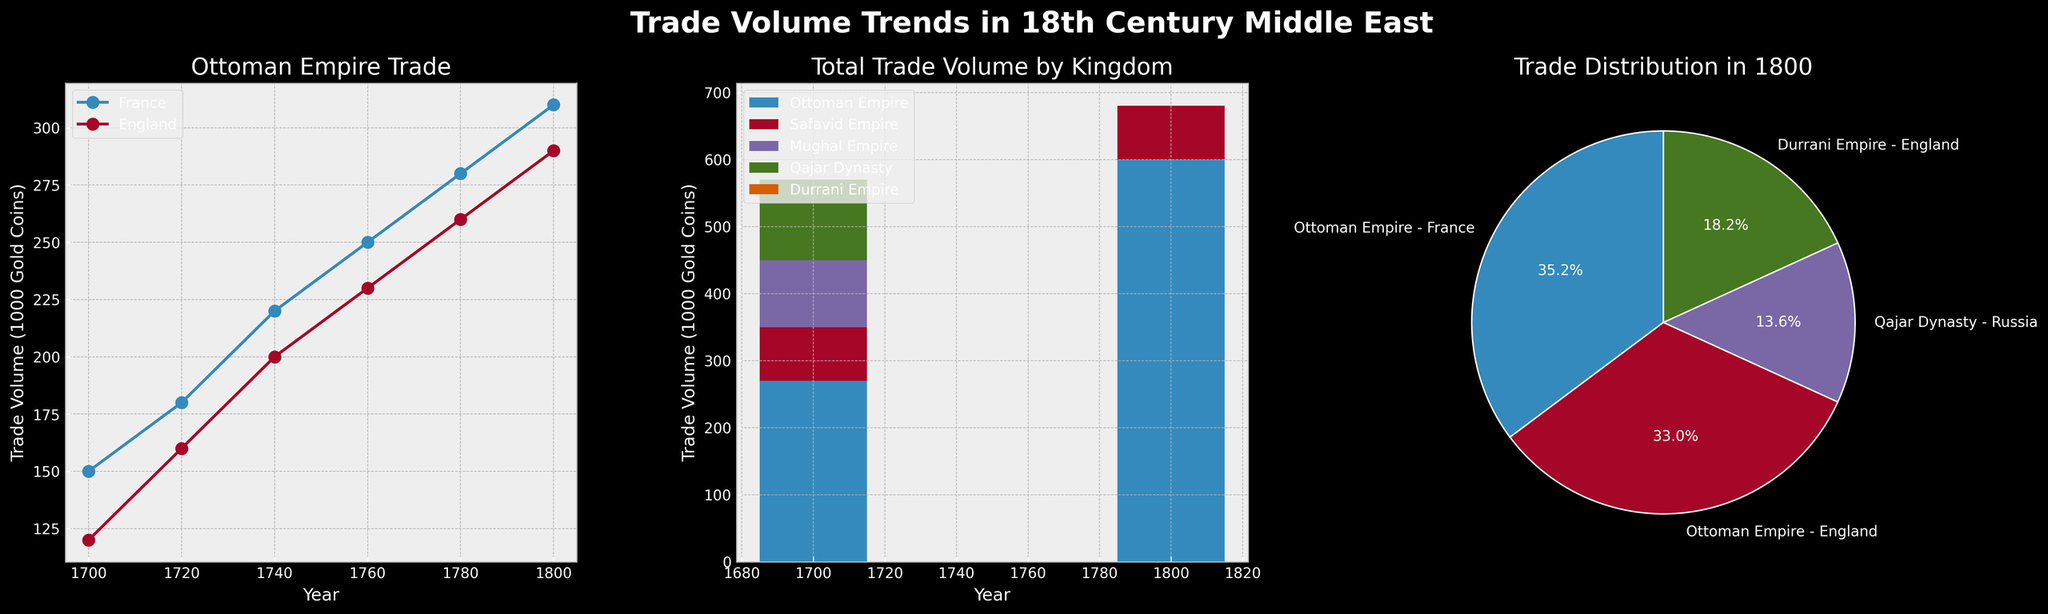What's the overall trend in trade between the Ottoman Empire and France from 1700 to 1800? By examining the line plot for the Ottoman Empire, we see a steady increase in trade volume with France. Each data point for the years 1700, 1720, 1740, 1760, 1780, and 1800 shows a rising line, indicating continuous growth.
Answer: Increasing Which kingdom had the highest total trade volume in 1700? Referring to the stacked bar chart for 1700, the Ottoman Empire has the largest segment, indicating the highest trade volume.
Answer: Ottoman Empire How does the relative trade volume between the Ottoman Empire and England change from 1700 to 1800? The line plot shows that the trade volume between the Ottoman Empire and England increases from 120 (in 1700) to 290 (in 1800), suggesting a significant growth over the century.
Answer: Increased In the year 1800, which European power had the largest share of trade with different Middle Eastern kingdoms? The pie chart shows multiple slices, with the largest slice labeled "Ottoman Empire - France," indicating that France had the largest share of trade in 1800.
Answer: France Compare the growth rates of trade volume between the Ottoman Empire and France versus the Ottoman Empire and England from 1700 to 1800. The plot for the Ottoman Empire shows the trade volume with France increasing from 150 to 310 (a growth of 160), and with England increasing from 120 to 290 (a growth of 170). While the volumes are different, the growth rates are 160 and 170, respectively, showing greater growth with England.
Answer: England higher growth What's the total trade volume across all kingdoms for the year 1800? The height of the bar for 1800 in the stacked bar chart sums up the various segments for each kingdom, which are 310 (Ottoman Empire - France), 290 (Ottoman Empire - England), 120 (Qajar Dynasty - Russia), and 160 (Durrani Empire - England). Therefore, the total is 310 + 290 + 120 + 160 = 880.
Answer: 880 Which new kingdoms emerged in the trade data between 1700 and 1800? Comparing the segments in the stacked bar chart for 1700 and 1800 shows that the 1700 bar doesn't include the Qajar Dynasty and Durrani Empire, which appear in 1800.
Answer: Qajar Dynasty, Durrani Empire What was the trade volume with Russia in the year 1760? From the line plot, we observe Russia's presence in trade with the Zand Dynasty with a trade volume of 85.
Answer: 85 How did the trade volume of the Mughal Empire with Portugal change from 1700 to 1740? Checking the stacked bar chart for these years shows the Mughal Empire's segment going from 100 to 95, indicating a slight decline.
Answer: Decreased 